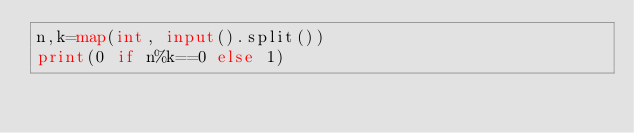<code> <loc_0><loc_0><loc_500><loc_500><_Python_>n,k=map(int, input().split())
print(0 if n%k==0 else 1)</code> 